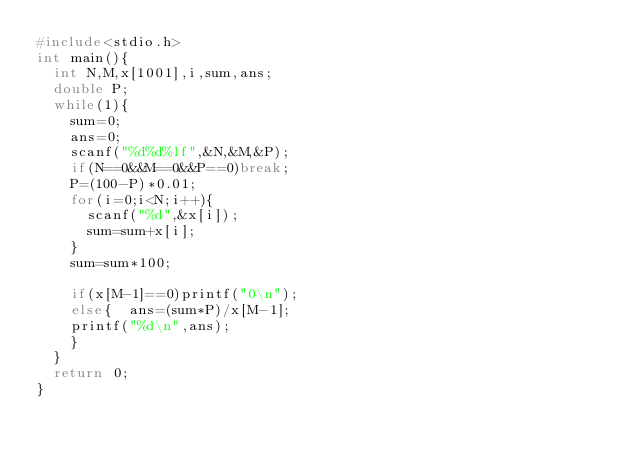Convert code to text. <code><loc_0><loc_0><loc_500><loc_500><_C_>#include<stdio.h>
int main(){
  int N,M,x[1001],i,sum,ans;
  double P;
  while(1){
    sum=0;
    ans=0;
    scanf("%d%d%lf",&N,&M,&P);
    if(N==0&&M==0&&P==0)break;
    P=(100-P)*0.01;
    for(i=0;i<N;i++){
      scanf("%d",&x[i]);
      sum=sum+x[i];
    }
    sum=sum*100;

    if(x[M-1]==0)printf("0\n");
    else{  ans=(sum*P)/x[M-1];
    printf("%d\n",ans);
    }
  }
  return 0;
}</code> 